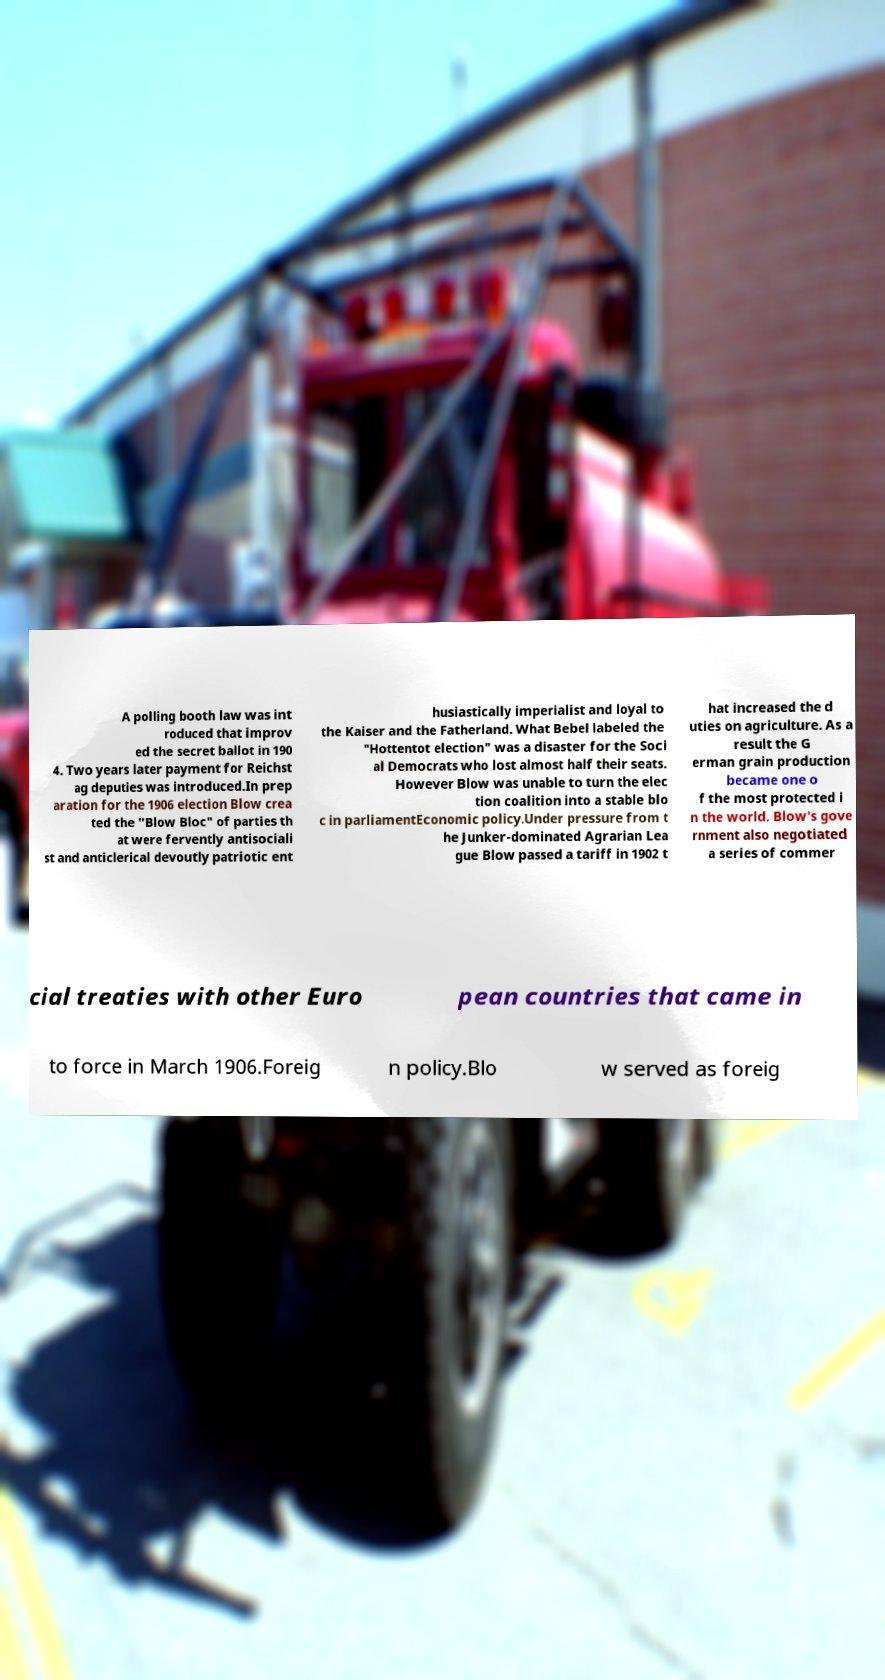Could you extract and type out the text from this image? A polling booth law was int roduced that improv ed the secret ballot in 190 4. Two years later payment for Reichst ag deputies was introduced.In prep aration for the 1906 election Blow crea ted the "Blow Bloc" of parties th at were fervently antisociali st and anticlerical devoutly patriotic ent husiastically imperialist and loyal to the Kaiser and the Fatherland. What Bebel labeled the "Hottentot election" was a disaster for the Soci al Democrats who lost almost half their seats. However Blow was unable to turn the elec tion coalition into a stable blo c in parliamentEconomic policy.Under pressure from t he Junker-dominated Agrarian Lea gue Blow passed a tariff in 1902 t hat increased the d uties on agriculture. As a result the G erman grain production became one o f the most protected i n the world. Blow's gove rnment also negotiated a series of commer cial treaties with other Euro pean countries that came in to force in March 1906.Foreig n policy.Blo w served as foreig 